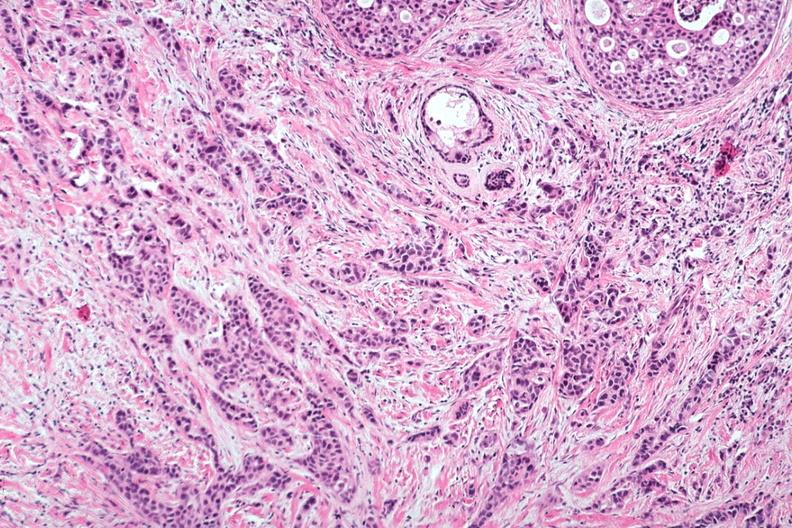re opened abdominal cavity with massive tumor in omentum none apparent in liver nor over peritoneal surfaces gut seen?
Answer the question using a single word or phrase. No 